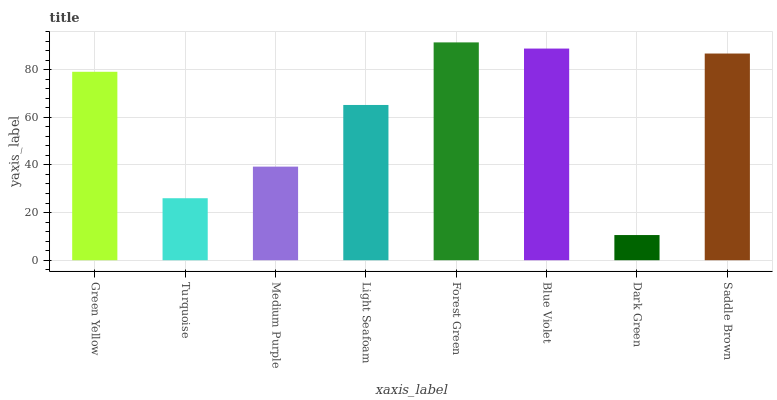Is Dark Green the minimum?
Answer yes or no. Yes. Is Forest Green the maximum?
Answer yes or no. Yes. Is Turquoise the minimum?
Answer yes or no. No. Is Turquoise the maximum?
Answer yes or no. No. Is Green Yellow greater than Turquoise?
Answer yes or no. Yes. Is Turquoise less than Green Yellow?
Answer yes or no. Yes. Is Turquoise greater than Green Yellow?
Answer yes or no. No. Is Green Yellow less than Turquoise?
Answer yes or no. No. Is Green Yellow the high median?
Answer yes or no. Yes. Is Light Seafoam the low median?
Answer yes or no. Yes. Is Turquoise the high median?
Answer yes or no. No. Is Medium Purple the low median?
Answer yes or no. No. 